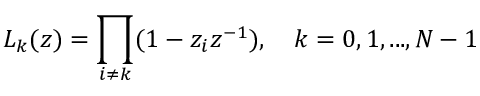Convert formula to latex. <formula><loc_0><loc_0><loc_500><loc_500>L _ { k } ( z ) = \prod _ { i \neq k } ( 1 - z _ { i } z ^ { - 1 } ) , \quad k = 0 , 1 , \dots , N - 1</formula> 